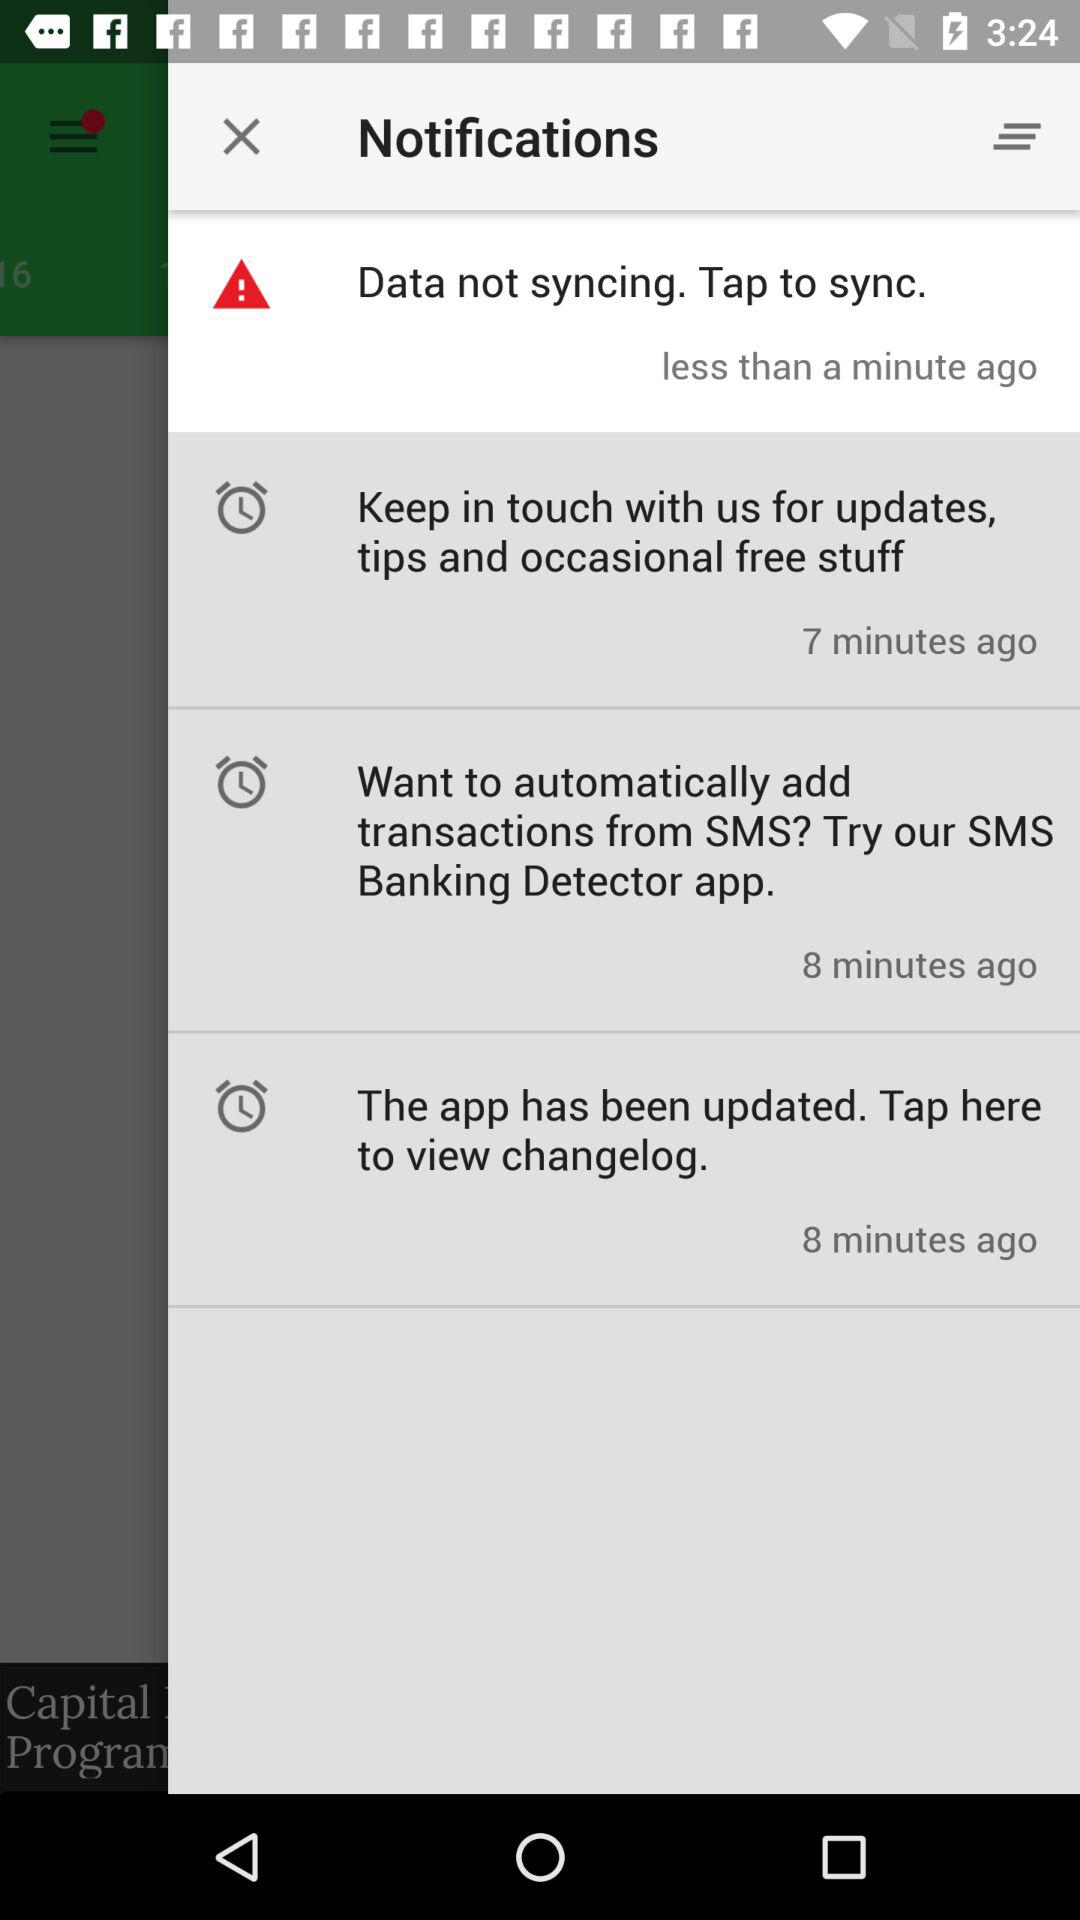What notification was received 7 minutes ago? The notification "Keep in touch with us for updates, tips and occasional free stuff" was received 7 minutes ago. 